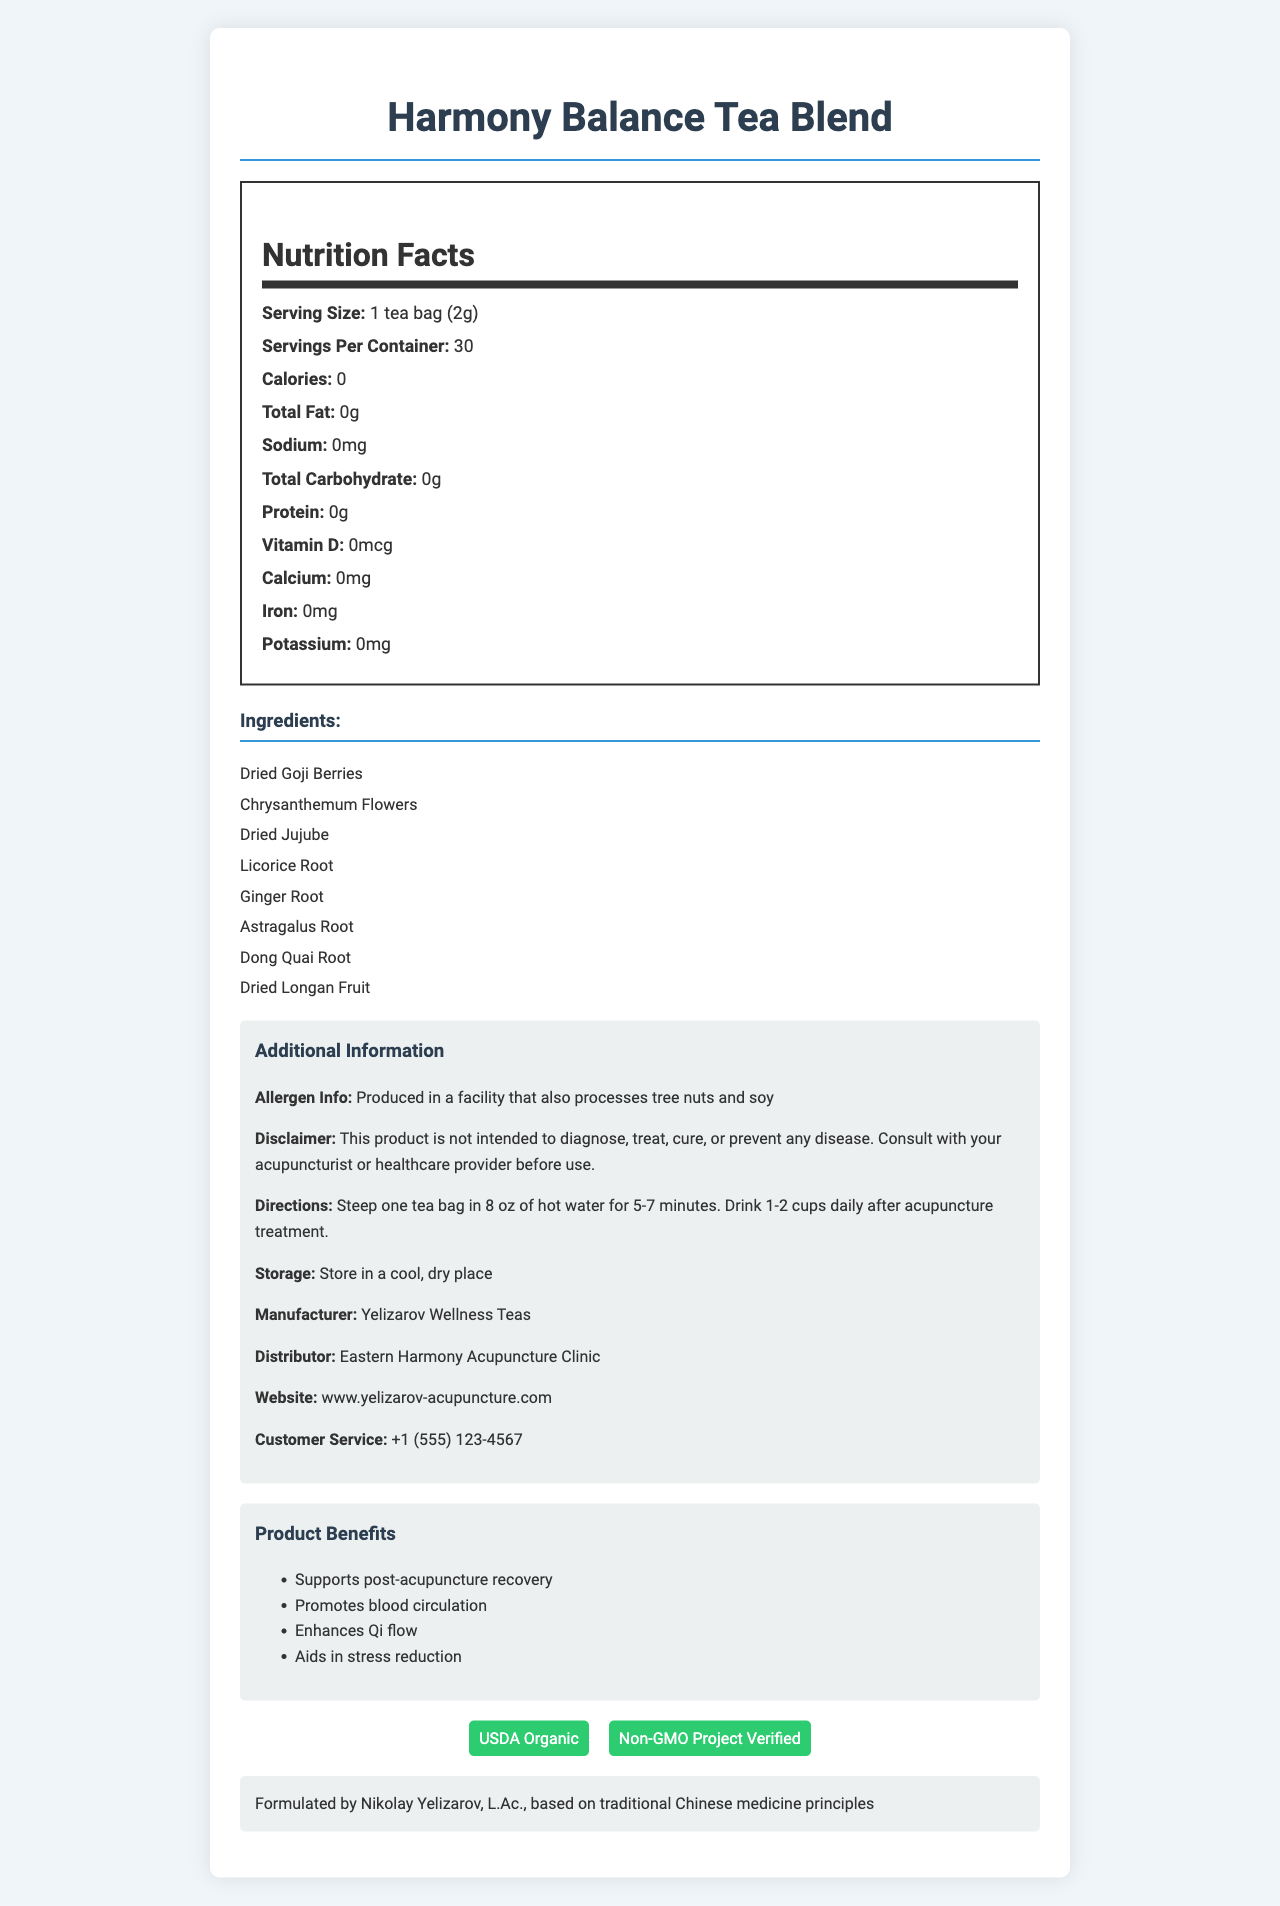what is the product name? The product name is clearly stated at the beginning of the document.
Answer: Harmony Balance Tea Blend how many servings are there per container? The document specifies that there are 30 servings per container.
Answer: 30 what is the serving size? The serving size is mentioned as "1 tea bag (2g)".
Answer: 1 tea bag (2g) what is the calorie count per serving? The nutritional facts section lists the calorie count per serving as 0.
Answer: 0 what are the ingredients in the tea blend? The ingredients are listed under the "Ingredients" section.
Answer: Dried Goji Berries, Chrysanthemum Flowers, Dried Jujube, Licorice Root, Ginger Root, Astragalus Root, Dong Quai Root, Dried Longan Fruit what are the product benefits mentioned? The product benefits are listed explicitly in the additional information section.
Answer: Supports post-acupuncture recovery, Promotes blood circulation, Enhances Qi flow, Aids in stress reduction does this tea blend contain any fat? The nutritional facts show that the total fat is 0g, which means there is no fat content.
Answer: No what is the website for more information? The website URL is provided in the additional information section.
Answer: www.yelizarov-acupuncture.com which allergen information is relevant to this product? The allergen information is specified under the additional information section.
Answer: Produced in a facility that also processes tree nuts and soy what is the contact number for customer service? The customer service number is included in the additional information section.
Answer: +1 (555) 123-4567 who formulated this tea blend? The additional information section states that the tea blend is formulated by Nikolay Yelizarov.
Answer: Nikolay Yelizarov, L.Ac. What certifications does this tea blend have? The certifications are listed under the certifications section and are also shown visually in the document.
Answer: USDA Organic, Non-GMO Project Verified where should this tea be stored? The storage instructions in the additional information section state this.
Answer: In a cool, dry place where is this tea blend produced? The document lists the distributor as Eastern Harmony Acupuncture Clinic, implying that it is produced there.
Answer: Eastern Harmony Acupuncture Clinic according to the document, what is the main purpose of this tea? The product benefits section lists these intended purposes.
Answer: Supports post-acupuncture recovery, Promotes blood circulation, Enhances Qi flow, Aids in stress reduction how many grams of protein does this tea contain? A. 0g B. 1g C. 2g D. 3g The nutritional facts section states the protein content as 0g.
Answer: A. 0g how many calories are there in one serving of this tea blend? A. 0 B. 5 C. 10 D. 20 The calorie count per serving is listed as 0 in the nutritional facts section.
Answer: A. 0 can this product diagnose, treat, cure, or prevent any disease? (Yes/No) The disclaimer clearly states that this product is not intended to diagnose, treat, cure, or prevent any disease.
Answer: No summarize the key information provided in the document. This summary includes the primary details about the tea blend, its nutritional content, ingredients, benefits, storage instructions, and disclaimers.
Answer: The Harmony Balance Tea Blend is a traditional Chinese medicine tea formulated by Nikolay Yelizarov, L.Ac., to support post-acupuncture recovery and overall wellness. It contains no calories, fat, protein, sodium, or carbohydrates and includes ingredients like Goji Berries and Chrysanthemum Flowers. The product is USDA Organic and Non-GMO Project Verified, and it should be used as directed and stored in a cool, dry place. It is produced in a facility that processes tree nuts and soy, and it is not intended to diagnose, treat, cure, or prevent any disease. What is the price of the tea blend? The document does not provide any details about the price of the tea blend.
Answer: Not enough information 